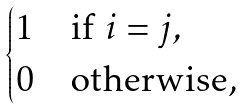Convert formula to latex. <formula><loc_0><loc_0><loc_500><loc_500>\begin{cases} 1 & { \text {if $i=j$} , } \\ 0 & { \text {otherwise,} } \end{cases}</formula> 